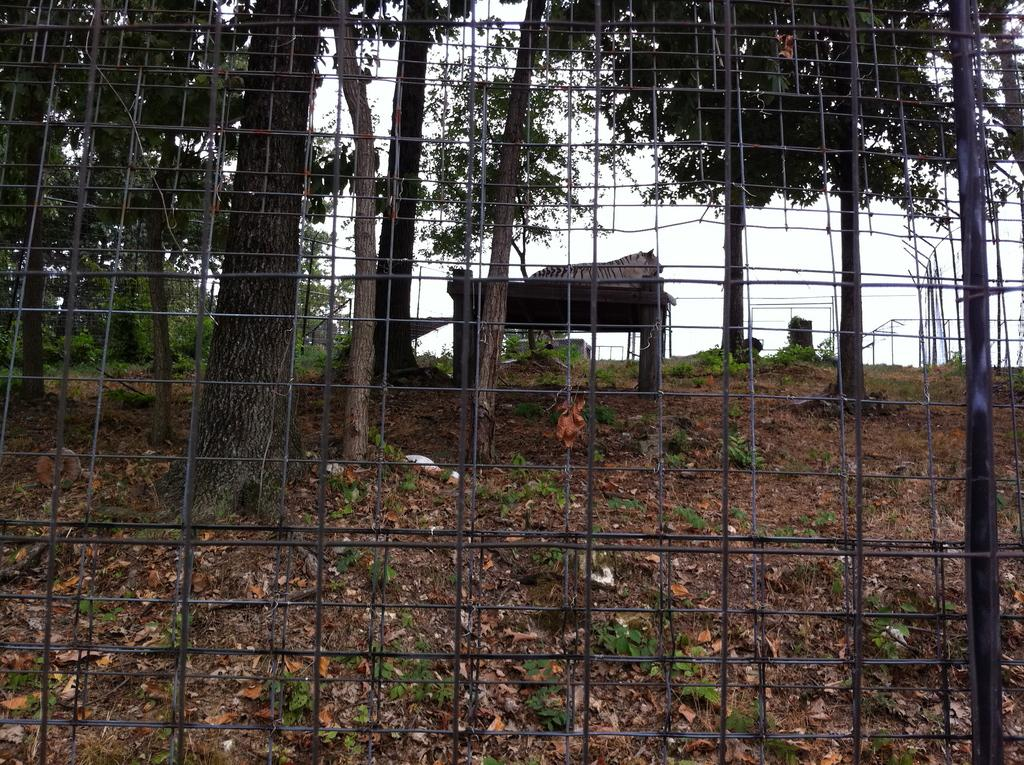What type of barrier can be seen in the image? There is a fence in the image. What is visible beyond the fence? A table is visible through the fence. What is on the table? There is an animal on the table. What type of vegetation is present in the image? There are trees and leaves in the image. What part of the natural environment is visible in the image? The sky is visible in the image. What type of society is depicted in the image? There is no society depicted in the image; it features a fence, a table, an animal, trees, leaves, and the sky. Is the animal on the table sleeping in the image? There is no indication of the animal's state of sleep in the image. 